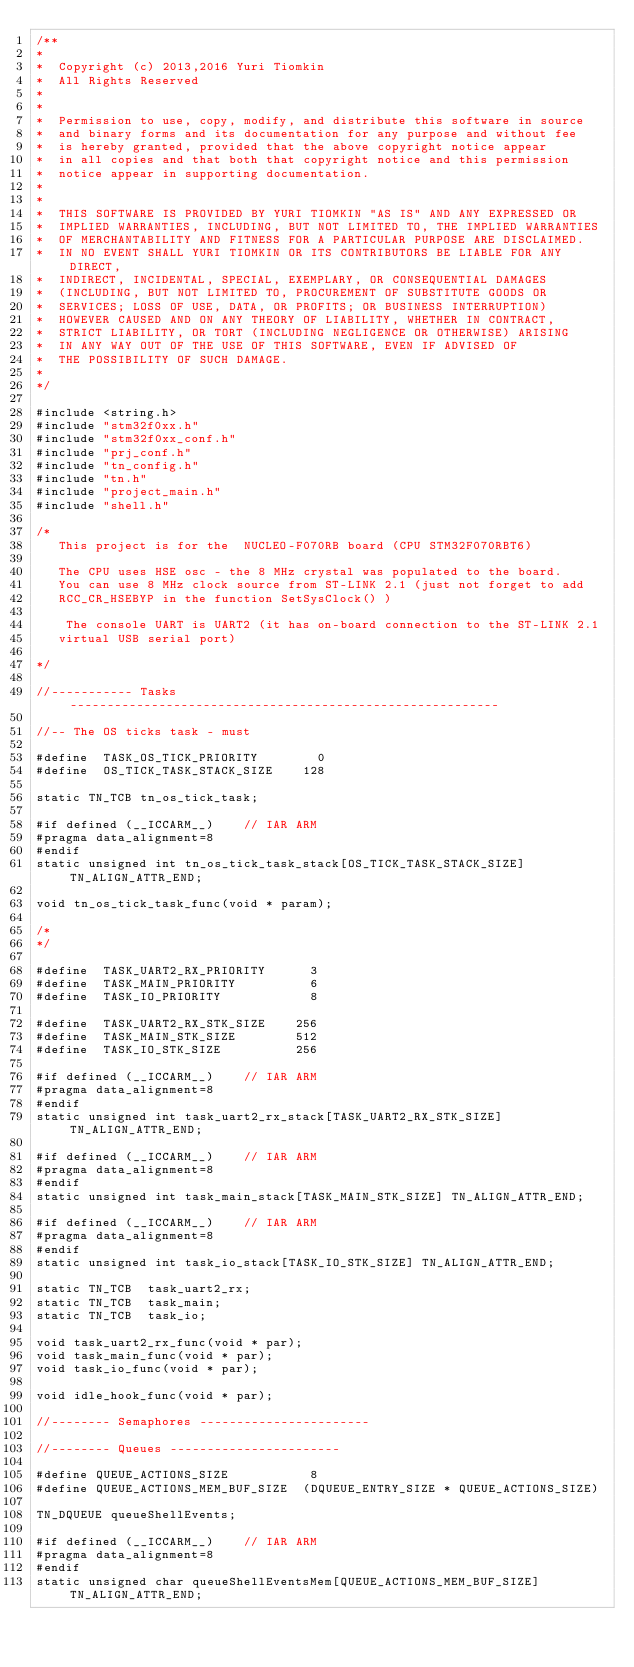Convert code to text. <code><loc_0><loc_0><loc_500><loc_500><_C_>/**
*
*  Copyright (c) 2013,2016 Yuri Tiomkin
*  All Rights Reserved
*
*
*  Permission to use, copy, modify, and distribute this software in source
*  and binary forms and its documentation for any purpose and without fee
*  is hereby granted, provided that the above copyright notice appear
*  in all copies and that both that copyright notice and this permission
*  notice appear in supporting documentation.
*
*
*  THIS SOFTWARE IS PROVIDED BY YURI TIOMKIN "AS IS" AND ANY EXPRESSED OR
*  IMPLIED WARRANTIES, INCLUDING, BUT NOT LIMITED TO, THE IMPLIED WARRANTIES
*  OF MERCHANTABILITY AND FITNESS FOR A PARTICULAR PURPOSE ARE DISCLAIMED.
*  IN NO EVENT SHALL YURI TIOMKIN OR ITS CONTRIBUTORS BE LIABLE FOR ANY DIRECT,
*  INDIRECT, INCIDENTAL, SPECIAL, EXEMPLARY, OR CONSEQUENTIAL DAMAGES
*  (INCLUDING, BUT NOT LIMITED TO, PROCUREMENT OF SUBSTITUTE GOODS OR
*  SERVICES; LOSS OF USE, DATA, OR PROFITS; OR BUSINESS INTERRUPTION)
*  HOWEVER CAUSED AND ON ANY THEORY OF LIABILITY, WHETHER IN CONTRACT,
*  STRICT LIABILITY, OR TORT (INCLUDING NEGLIGENCE OR OTHERWISE) ARISING
*  IN ANY WAY OUT OF THE USE OF THIS SOFTWARE, EVEN IF ADVISED OF
*  THE POSSIBILITY OF SUCH DAMAGE.
*
*/

#include <string.h>
#include "stm32f0xx.h"
#include "stm32f0xx_conf.h"
#include "prj_conf.h"
#include "tn_config.h"
#include "tn.h"
#include "project_main.h"
#include "shell.h"

/*
   This project is for the  NUCLEO-F070RB board (CPU STM32F070RBT6)

   The CPU uses HSE osc - the 8 MHz crystal was populated to the board.
   You can use 8 MHz clock source from ST-LINK 2.1 (just not forget to add 
   RCC_CR_HSEBYP in the function SetSysClock() )

    The console UART is UART2 (it has on-board connection to the ST-LINK 2.1
   virtual USB serial port)

*/

//----------- Tasks ----------------------------------------------------------

//-- The OS ticks task - must

#define  TASK_OS_TICK_PRIORITY        0
#define  OS_TICK_TASK_STACK_SIZE    128

static TN_TCB tn_os_tick_task;

#if defined (__ICCARM__)    // IAR ARM
#pragma data_alignment=8
#endif
static unsigned int tn_os_tick_task_stack[OS_TICK_TASK_STACK_SIZE] TN_ALIGN_ATTR_END;

void tn_os_tick_task_func(void * param);

/*
*/

#define  TASK_UART2_RX_PRIORITY      3
#define  TASK_MAIN_PRIORITY          6
#define  TASK_IO_PRIORITY            8

#define  TASK_UART2_RX_STK_SIZE    256
#define  TASK_MAIN_STK_SIZE        512
#define  TASK_IO_STK_SIZE          256

#if defined (__ICCARM__)    // IAR ARM
#pragma data_alignment=8
#endif
static unsigned int task_uart2_rx_stack[TASK_UART2_RX_STK_SIZE] TN_ALIGN_ATTR_END;

#if defined (__ICCARM__)    // IAR ARM
#pragma data_alignment=8
#endif
static unsigned int task_main_stack[TASK_MAIN_STK_SIZE] TN_ALIGN_ATTR_END;

#if defined (__ICCARM__)    // IAR ARM
#pragma data_alignment=8
#endif
static unsigned int task_io_stack[TASK_IO_STK_SIZE] TN_ALIGN_ATTR_END;

static TN_TCB  task_uart2_rx;
static TN_TCB  task_main;
static TN_TCB  task_io;

void task_uart2_rx_func(void * par);
void task_main_func(void * par);
void task_io_func(void * par);

void idle_hook_func(void * par);

//-------- Semaphores -----------------------

//-------- Queues -----------------------

#define QUEUE_ACTIONS_SIZE           8
#define QUEUE_ACTIONS_MEM_BUF_SIZE  (DQUEUE_ENTRY_SIZE * QUEUE_ACTIONS_SIZE)

TN_DQUEUE queueShellEvents;

#if defined (__ICCARM__)    // IAR ARM
#pragma data_alignment=8
#endif
static unsigned char queueShellEventsMem[QUEUE_ACTIONS_MEM_BUF_SIZE]  TN_ALIGN_ATTR_END;
</code> 